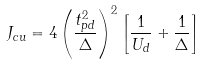<formula> <loc_0><loc_0><loc_500><loc_500>J _ { c u } = 4 \left ( \frac { t ^ { 2 } _ { p d } } { \Delta } \right ) ^ { 2 } \left [ \frac { 1 } { U _ { d } } + \frac { 1 } { \Delta } \right ]</formula> 